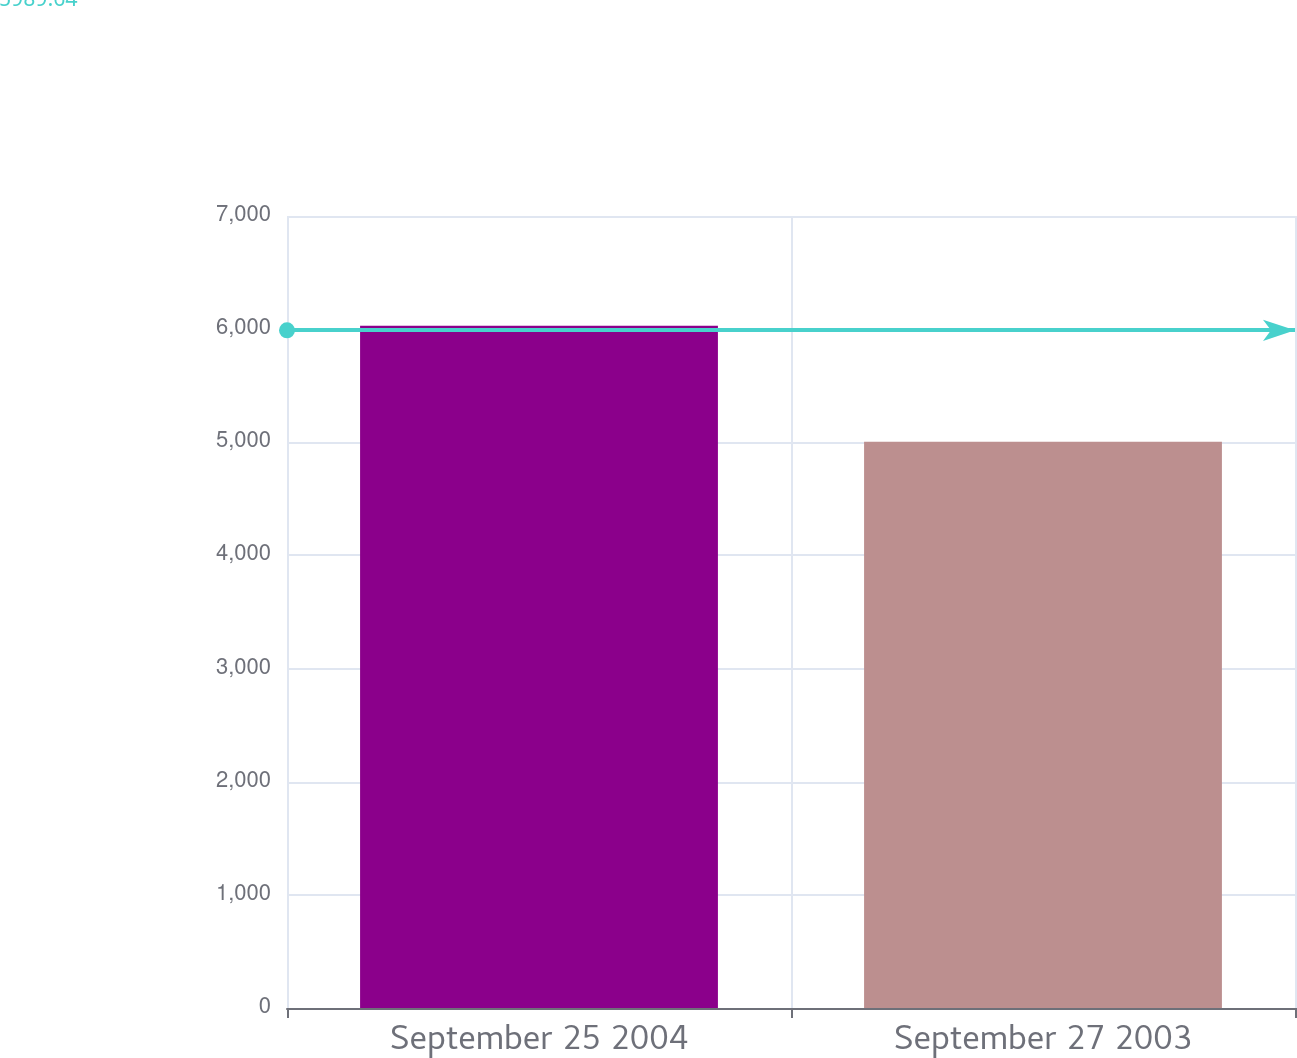<chart> <loc_0><loc_0><loc_500><loc_500><bar_chart><fcel>September 25 2004<fcel>September 27 2003<nl><fcel>6029<fcel>5005<nl></chart> 